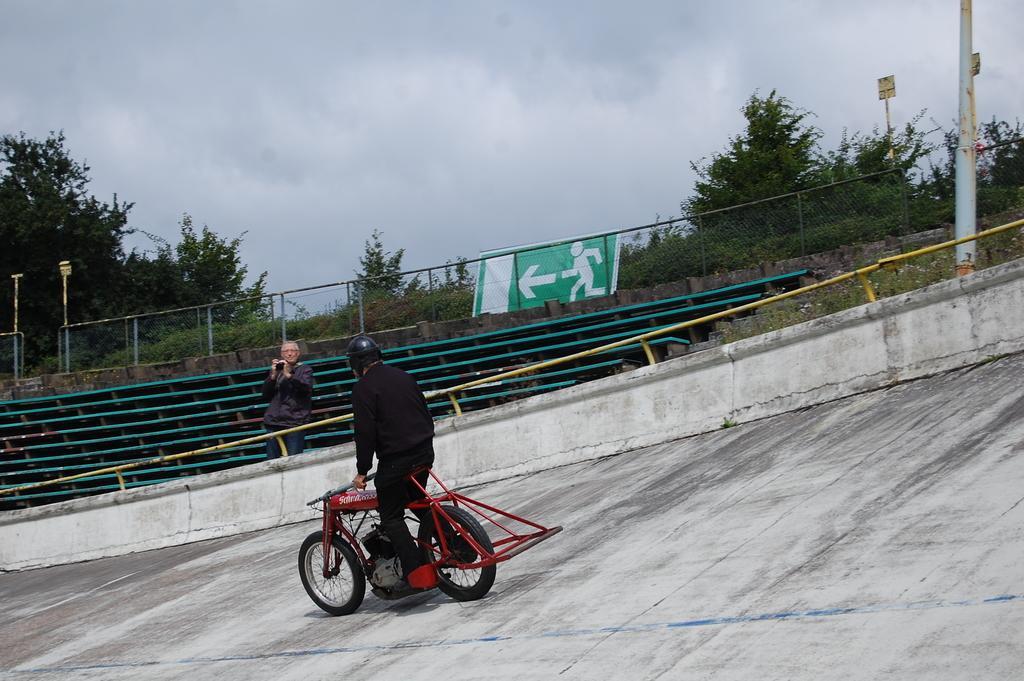Could you give a brief overview of what you see in this image? As we can see in the image, there are trees, fence, banner and two persons and this person is riding bicycle. 